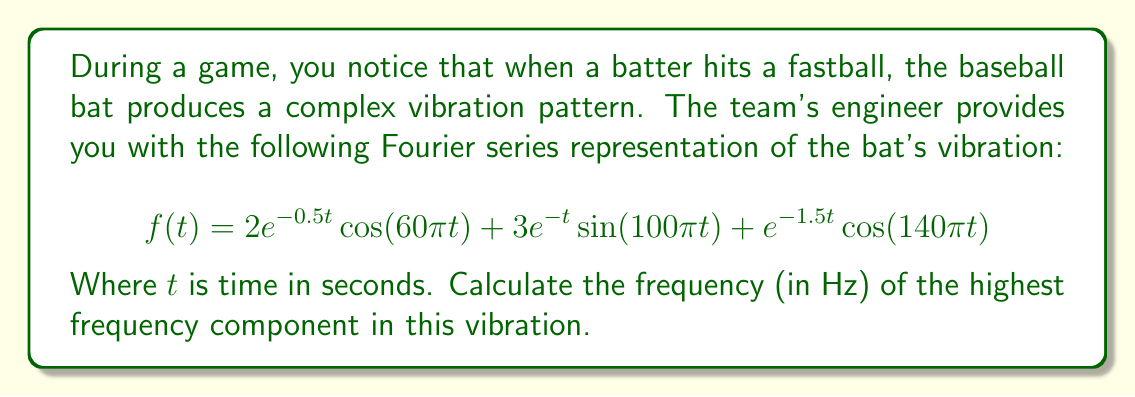Provide a solution to this math problem. To find the highest frequency component, we need to analyze each term in the Fourier series:

1) First term: $2e^{-0.5t}\cos(60\pi t)$
   The frequency is $60\pi$ rad/s

2) Second term: $3e^{-t}\sin(100\pi t)$
   The frequency is $100\pi$ rad/s

3) Third term: $e^{-1.5t}\cos(140\pi t)$
   The frequency is $140\pi$ rad/s

The highest frequency is $140\pi$ rad/s.

To convert from angular frequency (rad/s) to frequency (Hz), we use the formula:

$$f = \frac{\omega}{2\pi}$$

Where $f$ is frequency in Hz and $\omega$ is angular frequency in rad/s.

Substituting $140\pi$ for $\omega$:

$$f = \frac{140\pi}{2\pi} = 70\text{ Hz}$$

Therefore, the highest frequency component in the vibration is 70 Hz.
Answer: 70 Hz 